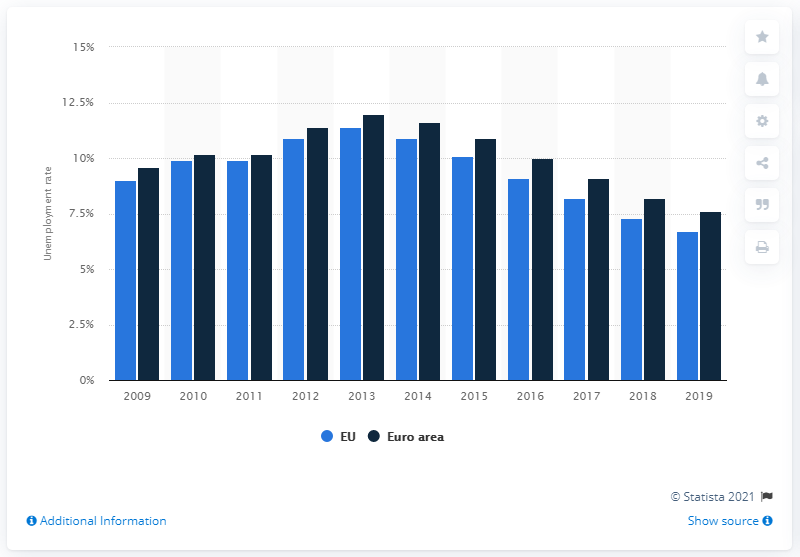Outline some significant characteristics in this image. The average unemployment rate in the EU in 2019 was 6.7%. 